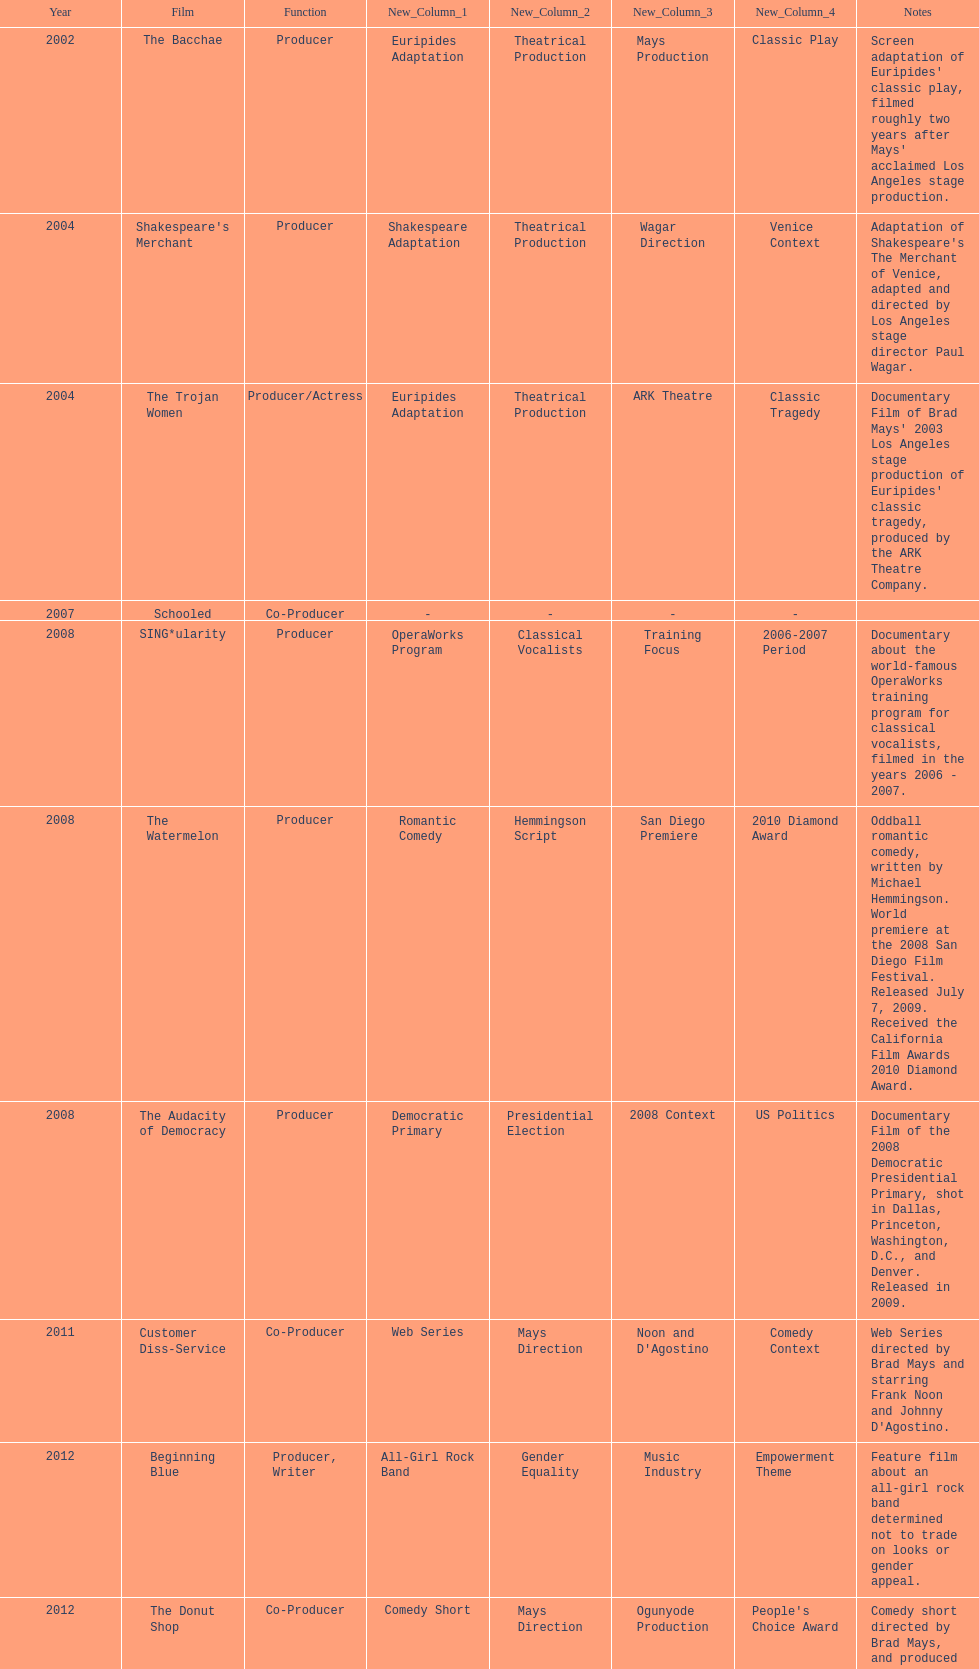How many films did ms. starfelt produce after 2010? 4. 